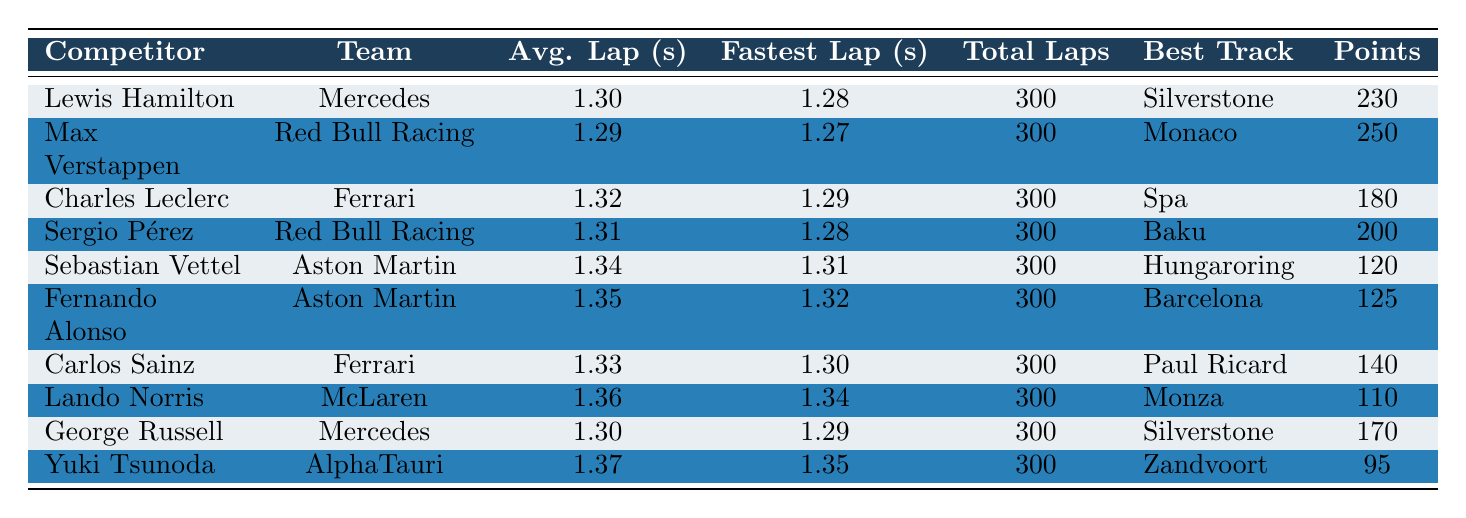What was the fastest lap time recorded during the 2023 season? By examining the "Fastest Lap (s)" column, the fastest recorded lap time is 1.27 seconds, attributed to Max Verstappen.
Answer: 1.27 Which competitor had the highest average lap time? The competitor with the highest average lap time is Yuki Tsunoda, with an average of 1.37 seconds.
Answer: 1.37 What is the total number of points scored by the top three competitors? Summing the points for the top three competitors: Max Verstappen (250) + Lewis Hamilton (230) + Sergio Pérez (200) gives a total of 680 points.
Answer: 680 Did Fernando Alonso score more points than Carlos Sainz? Fernando Alonso scored 125 points, whereas Carlos Sainz earned 140 points, meaning Alonso scored less than Sainz.
Answer: No Which competitor achieved their fastest lap at the Monaco track? According to the "Best Track" column, Max Verstappen is the one who achieved his fastest lap at the Monaco track.
Answer: Max Verstappen What is the average lap time difference between the competitors at the top and bottom of the rankings? The average lap time of the top competitor, Max Verstappen, is 1.29 seconds, and the bottom competitor, Yuki Tsunoda, is 1.37 seconds. The difference is 1.37 - 1.29 = 0.08 seconds.
Answer: 0.08 How many competitors scored less than 150 season points? Reviewing the "Points" column, the competitors scoring below 150 points are Sebastian Vettel (120), Fernando Alonso (125), Carlos Sainz (140), Lando Norris (110), and Yuki Tsunoda (95). This totals 5 competitors.
Answer: 5 Which team had the best average lap time based on their top competitor? Looking at the fastest average lap times: Mercedes with Lewis Hamilton (1.30) and George Russell (1.30) and Red Bull Racing with Max Verstappen (1.29) and Sergio Pérez (1.31). Red Bull Racing has the best average lap time at 1.29 seconds.
Answer: Red Bull Racing 